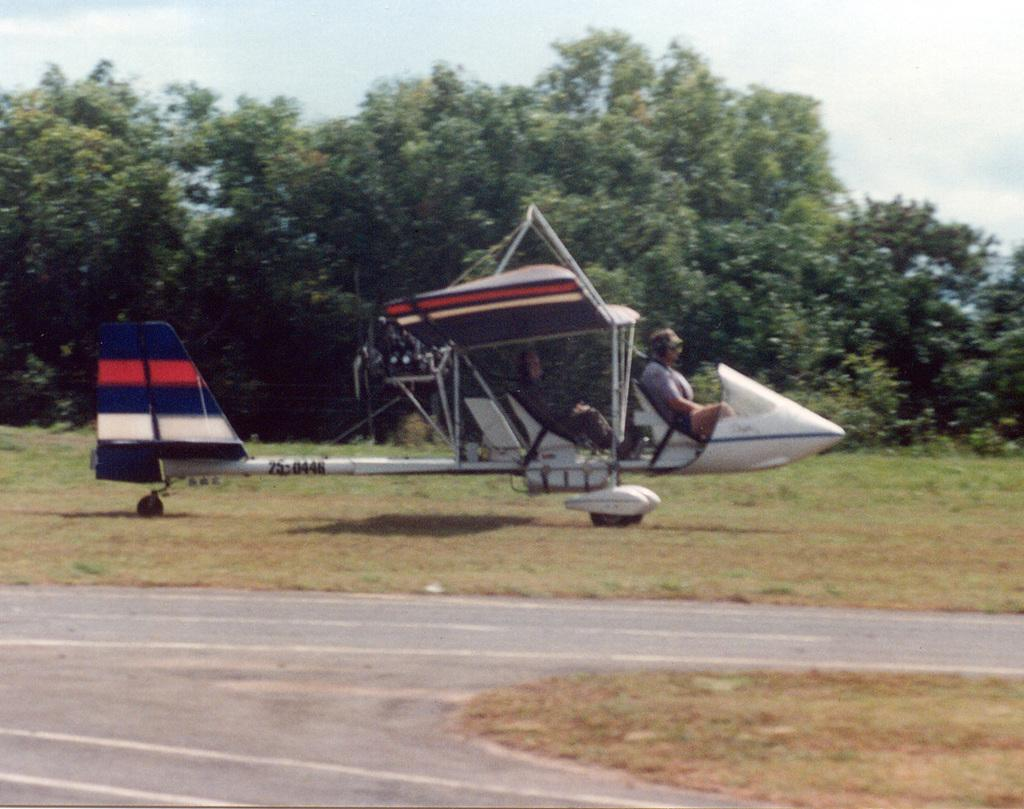What are the people in the image doing? The people in the image are sitting in the aircraft. What can be seen outside the aircraft? There is a road visible in the image. What type of natural scenery is visible in the background? There are trees in the background of the image. What is visible in the sky in the image? The sky is visible in the background of the image. How many beds can be seen in the image? There are no beds present in the image. What color is the woman's eye in the image? There are no women or eyes present in the image. 